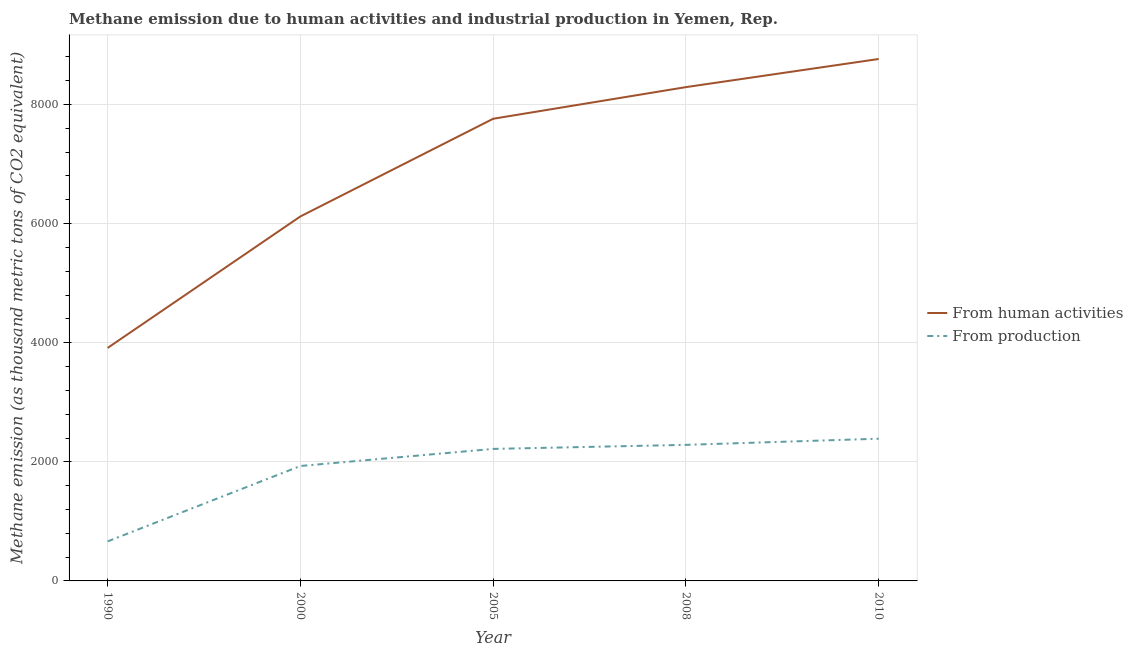How many different coloured lines are there?
Your response must be concise. 2. Does the line corresponding to amount of emissions generated from industries intersect with the line corresponding to amount of emissions from human activities?
Your answer should be very brief. No. Is the number of lines equal to the number of legend labels?
Give a very brief answer. Yes. What is the amount of emissions from human activities in 1990?
Your answer should be very brief. 3912.6. Across all years, what is the maximum amount of emissions generated from industries?
Your answer should be compact. 2388.3. Across all years, what is the minimum amount of emissions generated from industries?
Your answer should be very brief. 664. In which year was the amount of emissions generated from industries maximum?
Provide a short and direct response. 2010. What is the total amount of emissions generated from industries in the graph?
Ensure brevity in your answer.  9484.2. What is the difference between the amount of emissions from human activities in 2008 and that in 2010?
Ensure brevity in your answer.  -472.3. What is the difference between the amount of emissions from human activities in 2000 and the amount of emissions generated from industries in 2010?
Ensure brevity in your answer.  3732.8. What is the average amount of emissions from human activities per year?
Provide a short and direct response. 6970.38. In the year 2000, what is the difference between the amount of emissions from human activities and amount of emissions generated from industries?
Ensure brevity in your answer.  4191. In how many years, is the amount of emissions from human activities greater than 8400 thousand metric tons?
Keep it short and to the point. 1. What is the ratio of the amount of emissions from human activities in 2000 to that in 2010?
Offer a terse response. 0.7. Is the amount of emissions generated from industries in 1990 less than that in 2008?
Offer a very short reply. Yes. Is the difference between the amount of emissions from human activities in 2000 and 2010 greater than the difference between the amount of emissions generated from industries in 2000 and 2010?
Provide a short and direct response. No. What is the difference between the highest and the second highest amount of emissions from human activities?
Offer a terse response. 472.3. What is the difference between the highest and the lowest amount of emissions from human activities?
Provide a succinct answer. 4852.1. In how many years, is the amount of emissions generated from industries greater than the average amount of emissions generated from industries taken over all years?
Make the answer very short. 4. Does the amount of emissions from human activities monotonically increase over the years?
Offer a very short reply. Yes. Is the amount of emissions from human activities strictly greater than the amount of emissions generated from industries over the years?
Your answer should be very brief. Yes. How many lines are there?
Give a very brief answer. 2. How many years are there in the graph?
Ensure brevity in your answer.  5. Are the values on the major ticks of Y-axis written in scientific E-notation?
Give a very brief answer. No. Does the graph contain any zero values?
Ensure brevity in your answer.  No. How are the legend labels stacked?
Provide a short and direct response. Vertical. What is the title of the graph?
Keep it short and to the point. Methane emission due to human activities and industrial production in Yemen, Rep. What is the label or title of the Y-axis?
Ensure brevity in your answer.  Methane emission (as thousand metric tons of CO2 equivalent). What is the Methane emission (as thousand metric tons of CO2 equivalent) of From human activities in 1990?
Offer a very short reply. 3912.6. What is the Methane emission (as thousand metric tons of CO2 equivalent) of From production in 1990?
Your answer should be compact. 664. What is the Methane emission (as thousand metric tons of CO2 equivalent) of From human activities in 2000?
Offer a very short reply. 6121.1. What is the Methane emission (as thousand metric tons of CO2 equivalent) in From production in 2000?
Provide a short and direct response. 1930.1. What is the Methane emission (as thousand metric tons of CO2 equivalent) in From human activities in 2005?
Offer a very short reply. 7761.1. What is the Methane emission (as thousand metric tons of CO2 equivalent) of From production in 2005?
Provide a succinct answer. 2216.9. What is the Methane emission (as thousand metric tons of CO2 equivalent) in From human activities in 2008?
Keep it short and to the point. 8292.4. What is the Methane emission (as thousand metric tons of CO2 equivalent) in From production in 2008?
Your answer should be compact. 2284.9. What is the Methane emission (as thousand metric tons of CO2 equivalent) in From human activities in 2010?
Provide a succinct answer. 8764.7. What is the Methane emission (as thousand metric tons of CO2 equivalent) of From production in 2010?
Keep it short and to the point. 2388.3. Across all years, what is the maximum Methane emission (as thousand metric tons of CO2 equivalent) of From human activities?
Your response must be concise. 8764.7. Across all years, what is the maximum Methane emission (as thousand metric tons of CO2 equivalent) of From production?
Your answer should be very brief. 2388.3. Across all years, what is the minimum Methane emission (as thousand metric tons of CO2 equivalent) in From human activities?
Ensure brevity in your answer.  3912.6. Across all years, what is the minimum Methane emission (as thousand metric tons of CO2 equivalent) in From production?
Give a very brief answer. 664. What is the total Methane emission (as thousand metric tons of CO2 equivalent) of From human activities in the graph?
Your response must be concise. 3.49e+04. What is the total Methane emission (as thousand metric tons of CO2 equivalent) of From production in the graph?
Your answer should be compact. 9484.2. What is the difference between the Methane emission (as thousand metric tons of CO2 equivalent) of From human activities in 1990 and that in 2000?
Ensure brevity in your answer.  -2208.5. What is the difference between the Methane emission (as thousand metric tons of CO2 equivalent) of From production in 1990 and that in 2000?
Provide a succinct answer. -1266.1. What is the difference between the Methane emission (as thousand metric tons of CO2 equivalent) of From human activities in 1990 and that in 2005?
Provide a succinct answer. -3848.5. What is the difference between the Methane emission (as thousand metric tons of CO2 equivalent) in From production in 1990 and that in 2005?
Ensure brevity in your answer.  -1552.9. What is the difference between the Methane emission (as thousand metric tons of CO2 equivalent) in From human activities in 1990 and that in 2008?
Make the answer very short. -4379.8. What is the difference between the Methane emission (as thousand metric tons of CO2 equivalent) of From production in 1990 and that in 2008?
Offer a very short reply. -1620.9. What is the difference between the Methane emission (as thousand metric tons of CO2 equivalent) of From human activities in 1990 and that in 2010?
Make the answer very short. -4852.1. What is the difference between the Methane emission (as thousand metric tons of CO2 equivalent) in From production in 1990 and that in 2010?
Ensure brevity in your answer.  -1724.3. What is the difference between the Methane emission (as thousand metric tons of CO2 equivalent) in From human activities in 2000 and that in 2005?
Make the answer very short. -1640. What is the difference between the Methane emission (as thousand metric tons of CO2 equivalent) of From production in 2000 and that in 2005?
Offer a very short reply. -286.8. What is the difference between the Methane emission (as thousand metric tons of CO2 equivalent) of From human activities in 2000 and that in 2008?
Your answer should be very brief. -2171.3. What is the difference between the Methane emission (as thousand metric tons of CO2 equivalent) in From production in 2000 and that in 2008?
Give a very brief answer. -354.8. What is the difference between the Methane emission (as thousand metric tons of CO2 equivalent) of From human activities in 2000 and that in 2010?
Make the answer very short. -2643.6. What is the difference between the Methane emission (as thousand metric tons of CO2 equivalent) in From production in 2000 and that in 2010?
Give a very brief answer. -458.2. What is the difference between the Methane emission (as thousand metric tons of CO2 equivalent) in From human activities in 2005 and that in 2008?
Offer a very short reply. -531.3. What is the difference between the Methane emission (as thousand metric tons of CO2 equivalent) in From production in 2005 and that in 2008?
Offer a very short reply. -68. What is the difference between the Methane emission (as thousand metric tons of CO2 equivalent) of From human activities in 2005 and that in 2010?
Offer a terse response. -1003.6. What is the difference between the Methane emission (as thousand metric tons of CO2 equivalent) in From production in 2005 and that in 2010?
Offer a terse response. -171.4. What is the difference between the Methane emission (as thousand metric tons of CO2 equivalent) in From human activities in 2008 and that in 2010?
Your response must be concise. -472.3. What is the difference between the Methane emission (as thousand metric tons of CO2 equivalent) in From production in 2008 and that in 2010?
Your response must be concise. -103.4. What is the difference between the Methane emission (as thousand metric tons of CO2 equivalent) in From human activities in 1990 and the Methane emission (as thousand metric tons of CO2 equivalent) in From production in 2000?
Provide a succinct answer. 1982.5. What is the difference between the Methane emission (as thousand metric tons of CO2 equivalent) of From human activities in 1990 and the Methane emission (as thousand metric tons of CO2 equivalent) of From production in 2005?
Keep it short and to the point. 1695.7. What is the difference between the Methane emission (as thousand metric tons of CO2 equivalent) of From human activities in 1990 and the Methane emission (as thousand metric tons of CO2 equivalent) of From production in 2008?
Offer a terse response. 1627.7. What is the difference between the Methane emission (as thousand metric tons of CO2 equivalent) in From human activities in 1990 and the Methane emission (as thousand metric tons of CO2 equivalent) in From production in 2010?
Provide a short and direct response. 1524.3. What is the difference between the Methane emission (as thousand metric tons of CO2 equivalent) in From human activities in 2000 and the Methane emission (as thousand metric tons of CO2 equivalent) in From production in 2005?
Provide a succinct answer. 3904.2. What is the difference between the Methane emission (as thousand metric tons of CO2 equivalent) in From human activities in 2000 and the Methane emission (as thousand metric tons of CO2 equivalent) in From production in 2008?
Make the answer very short. 3836.2. What is the difference between the Methane emission (as thousand metric tons of CO2 equivalent) of From human activities in 2000 and the Methane emission (as thousand metric tons of CO2 equivalent) of From production in 2010?
Give a very brief answer. 3732.8. What is the difference between the Methane emission (as thousand metric tons of CO2 equivalent) of From human activities in 2005 and the Methane emission (as thousand metric tons of CO2 equivalent) of From production in 2008?
Offer a very short reply. 5476.2. What is the difference between the Methane emission (as thousand metric tons of CO2 equivalent) in From human activities in 2005 and the Methane emission (as thousand metric tons of CO2 equivalent) in From production in 2010?
Provide a short and direct response. 5372.8. What is the difference between the Methane emission (as thousand metric tons of CO2 equivalent) of From human activities in 2008 and the Methane emission (as thousand metric tons of CO2 equivalent) of From production in 2010?
Offer a terse response. 5904.1. What is the average Methane emission (as thousand metric tons of CO2 equivalent) in From human activities per year?
Give a very brief answer. 6970.38. What is the average Methane emission (as thousand metric tons of CO2 equivalent) in From production per year?
Your answer should be compact. 1896.84. In the year 1990, what is the difference between the Methane emission (as thousand metric tons of CO2 equivalent) of From human activities and Methane emission (as thousand metric tons of CO2 equivalent) of From production?
Offer a terse response. 3248.6. In the year 2000, what is the difference between the Methane emission (as thousand metric tons of CO2 equivalent) of From human activities and Methane emission (as thousand metric tons of CO2 equivalent) of From production?
Ensure brevity in your answer.  4191. In the year 2005, what is the difference between the Methane emission (as thousand metric tons of CO2 equivalent) in From human activities and Methane emission (as thousand metric tons of CO2 equivalent) in From production?
Keep it short and to the point. 5544.2. In the year 2008, what is the difference between the Methane emission (as thousand metric tons of CO2 equivalent) of From human activities and Methane emission (as thousand metric tons of CO2 equivalent) of From production?
Offer a very short reply. 6007.5. In the year 2010, what is the difference between the Methane emission (as thousand metric tons of CO2 equivalent) of From human activities and Methane emission (as thousand metric tons of CO2 equivalent) of From production?
Offer a terse response. 6376.4. What is the ratio of the Methane emission (as thousand metric tons of CO2 equivalent) of From human activities in 1990 to that in 2000?
Provide a succinct answer. 0.64. What is the ratio of the Methane emission (as thousand metric tons of CO2 equivalent) of From production in 1990 to that in 2000?
Your response must be concise. 0.34. What is the ratio of the Methane emission (as thousand metric tons of CO2 equivalent) of From human activities in 1990 to that in 2005?
Ensure brevity in your answer.  0.5. What is the ratio of the Methane emission (as thousand metric tons of CO2 equivalent) of From production in 1990 to that in 2005?
Your response must be concise. 0.3. What is the ratio of the Methane emission (as thousand metric tons of CO2 equivalent) of From human activities in 1990 to that in 2008?
Your response must be concise. 0.47. What is the ratio of the Methane emission (as thousand metric tons of CO2 equivalent) in From production in 1990 to that in 2008?
Give a very brief answer. 0.29. What is the ratio of the Methane emission (as thousand metric tons of CO2 equivalent) in From human activities in 1990 to that in 2010?
Your response must be concise. 0.45. What is the ratio of the Methane emission (as thousand metric tons of CO2 equivalent) in From production in 1990 to that in 2010?
Offer a very short reply. 0.28. What is the ratio of the Methane emission (as thousand metric tons of CO2 equivalent) in From human activities in 2000 to that in 2005?
Make the answer very short. 0.79. What is the ratio of the Methane emission (as thousand metric tons of CO2 equivalent) of From production in 2000 to that in 2005?
Offer a terse response. 0.87. What is the ratio of the Methane emission (as thousand metric tons of CO2 equivalent) of From human activities in 2000 to that in 2008?
Provide a succinct answer. 0.74. What is the ratio of the Methane emission (as thousand metric tons of CO2 equivalent) of From production in 2000 to that in 2008?
Keep it short and to the point. 0.84. What is the ratio of the Methane emission (as thousand metric tons of CO2 equivalent) in From human activities in 2000 to that in 2010?
Give a very brief answer. 0.7. What is the ratio of the Methane emission (as thousand metric tons of CO2 equivalent) in From production in 2000 to that in 2010?
Offer a very short reply. 0.81. What is the ratio of the Methane emission (as thousand metric tons of CO2 equivalent) in From human activities in 2005 to that in 2008?
Ensure brevity in your answer.  0.94. What is the ratio of the Methane emission (as thousand metric tons of CO2 equivalent) of From production in 2005 to that in 2008?
Provide a short and direct response. 0.97. What is the ratio of the Methane emission (as thousand metric tons of CO2 equivalent) in From human activities in 2005 to that in 2010?
Offer a very short reply. 0.89. What is the ratio of the Methane emission (as thousand metric tons of CO2 equivalent) in From production in 2005 to that in 2010?
Your answer should be very brief. 0.93. What is the ratio of the Methane emission (as thousand metric tons of CO2 equivalent) of From human activities in 2008 to that in 2010?
Your answer should be very brief. 0.95. What is the ratio of the Methane emission (as thousand metric tons of CO2 equivalent) of From production in 2008 to that in 2010?
Keep it short and to the point. 0.96. What is the difference between the highest and the second highest Methane emission (as thousand metric tons of CO2 equivalent) of From human activities?
Your response must be concise. 472.3. What is the difference between the highest and the second highest Methane emission (as thousand metric tons of CO2 equivalent) in From production?
Provide a succinct answer. 103.4. What is the difference between the highest and the lowest Methane emission (as thousand metric tons of CO2 equivalent) in From human activities?
Keep it short and to the point. 4852.1. What is the difference between the highest and the lowest Methane emission (as thousand metric tons of CO2 equivalent) of From production?
Your answer should be very brief. 1724.3. 